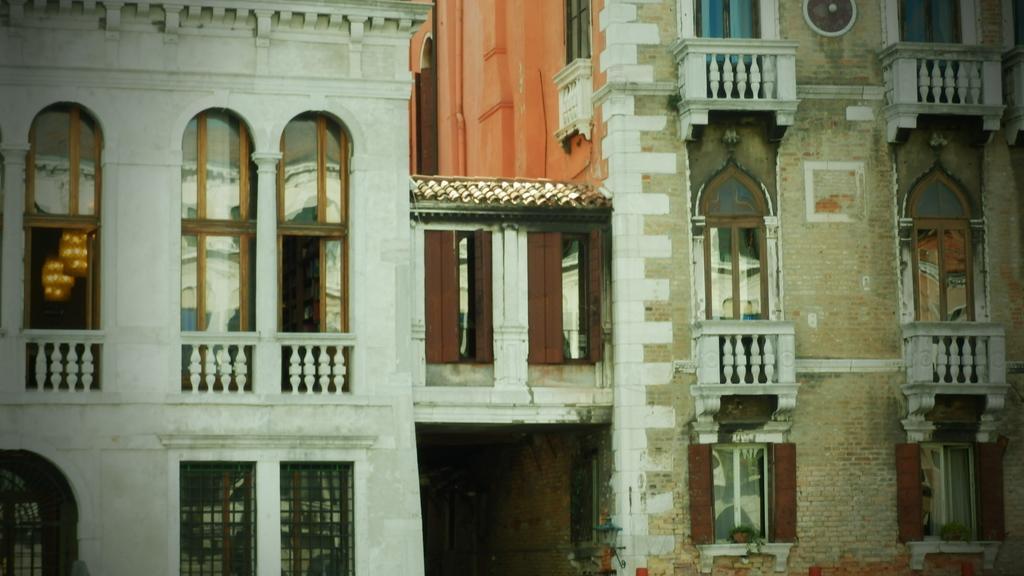In one or two sentences, can you explain what this image depicts? In the center of the image there is a buildings. There are windows. There is a railing. 